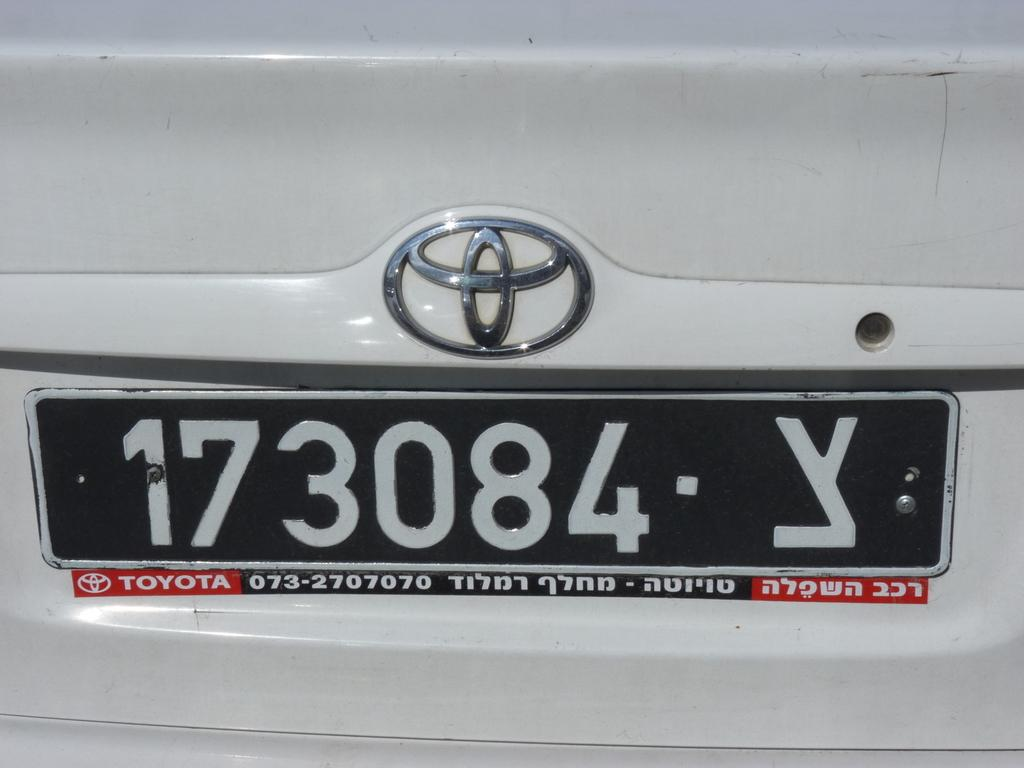<image>
Offer a succinct explanation of the picture presented. A license plate that has a black background and white letters and says Toyota underneath. 